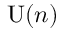Convert formula to latex. <formula><loc_0><loc_0><loc_500><loc_500>U ( n )</formula> 